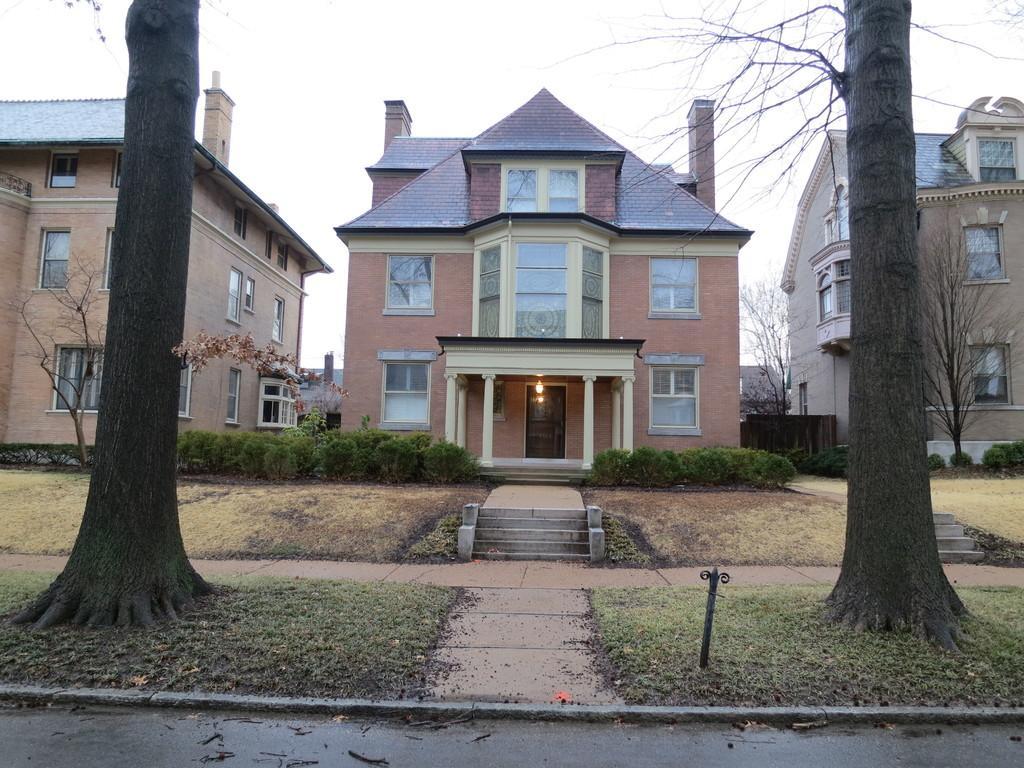Please provide a concise description of this image. In this image I can see a building which is in brown and cream color. I can also see few trees in green color and sky in white color. 